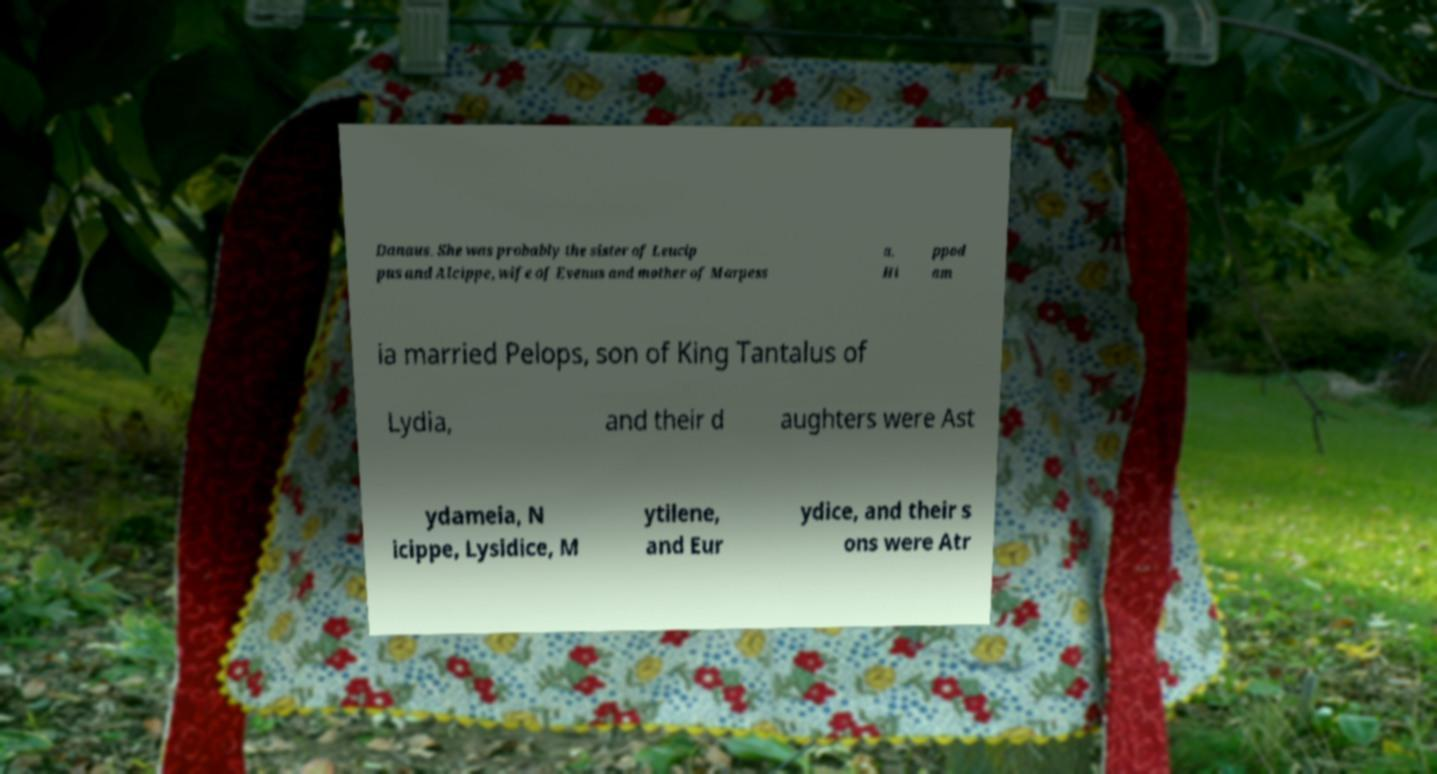For documentation purposes, I need the text within this image transcribed. Could you provide that? Danaus. She was probably the sister of Leucip pus and Alcippe, wife of Evenus and mother of Marpess a. Hi ppod am ia married Pelops, son of King Tantalus of Lydia, and their d aughters were Ast ydameia, N icippe, Lysidice, M ytilene, and Eur ydice, and their s ons were Atr 